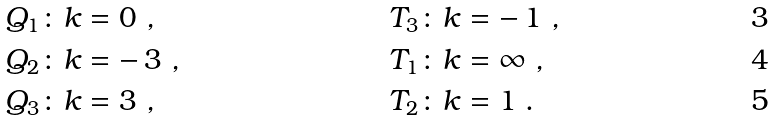Convert formula to latex. <formula><loc_0><loc_0><loc_500><loc_500>& Q _ { 1 } \colon k = 0 \ , & & T _ { 3 } \colon k = - \, 1 \ , \\ & Q _ { 2 } \colon k = - \, 3 \ , & & T _ { 1 } \colon k = \infty \ , \\ & Q _ { 3 } \colon k = 3 \ , & & T _ { 2 } \colon k = 1 \ .</formula> 